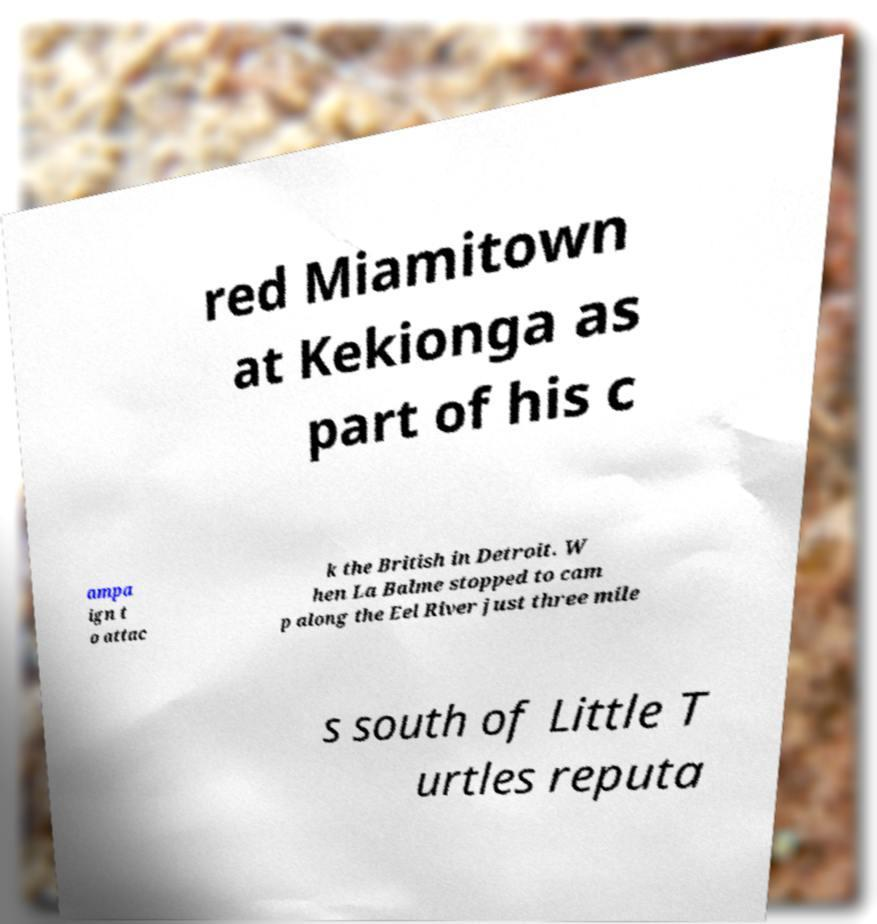Can you accurately transcribe the text from the provided image for me? red Miamitown at Kekionga as part of his c ampa ign t o attac k the British in Detroit. W hen La Balme stopped to cam p along the Eel River just three mile s south of Little T urtles reputa 